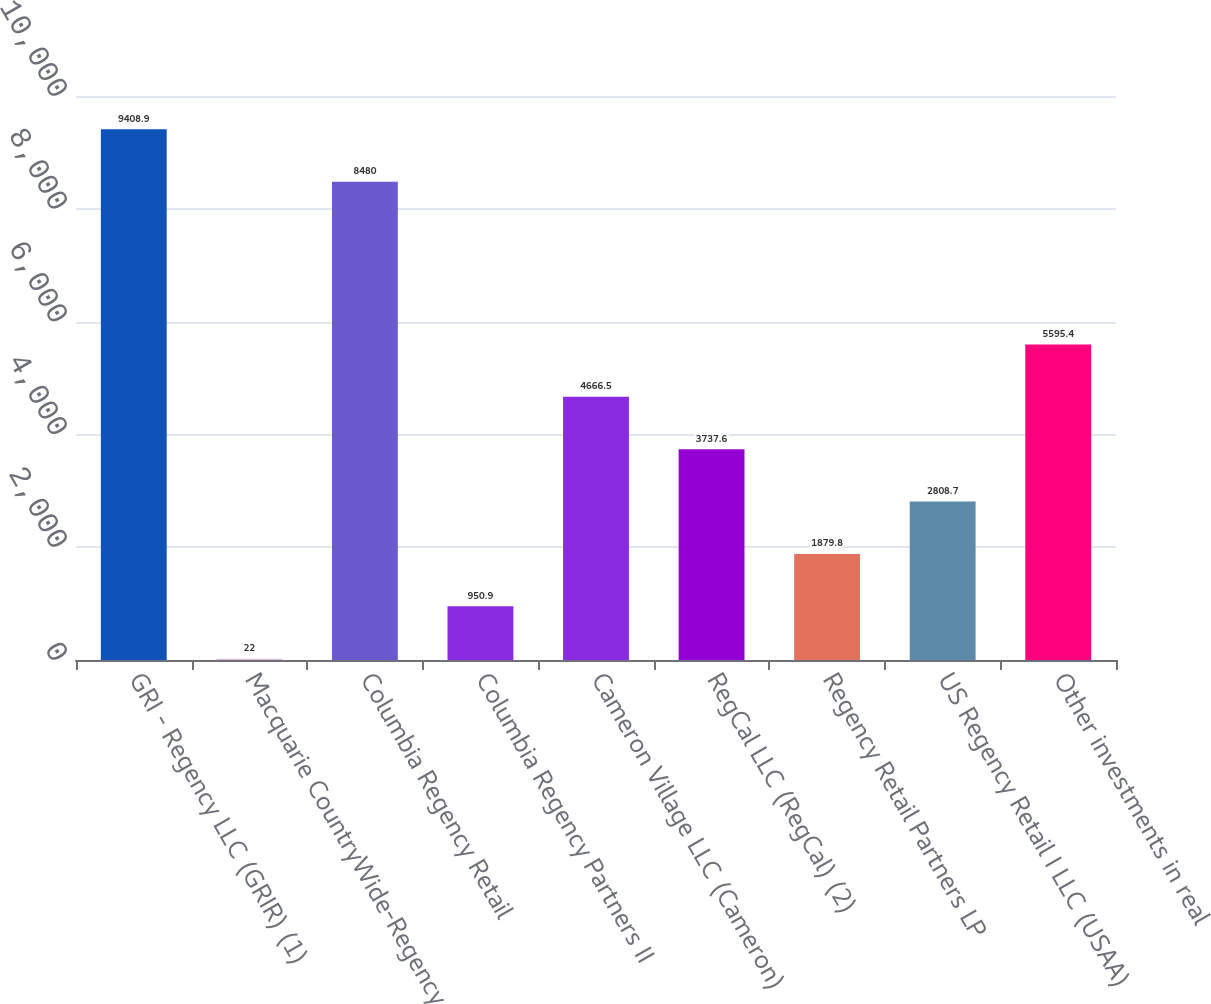Convert chart. <chart><loc_0><loc_0><loc_500><loc_500><bar_chart><fcel>GRI - Regency LLC (GRIR) (1)<fcel>Macquarie CountryWide-Regency<fcel>Columbia Regency Retail<fcel>Columbia Regency Partners II<fcel>Cameron Village LLC (Cameron)<fcel>RegCal LLC (RegCal) (2)<fcel>Regency Retail Partners LP<fcel>US Regency Retail I LLC (USAA)<fcel>Other investments in real<nl><fcel>9408.9<fcel>22<fcel>8480<fcel>950.9<fcel>4666.5<fcel>3737.6<fcel>1879.8<fcel>2808.7<fcel>5595.4<nl></chart> 